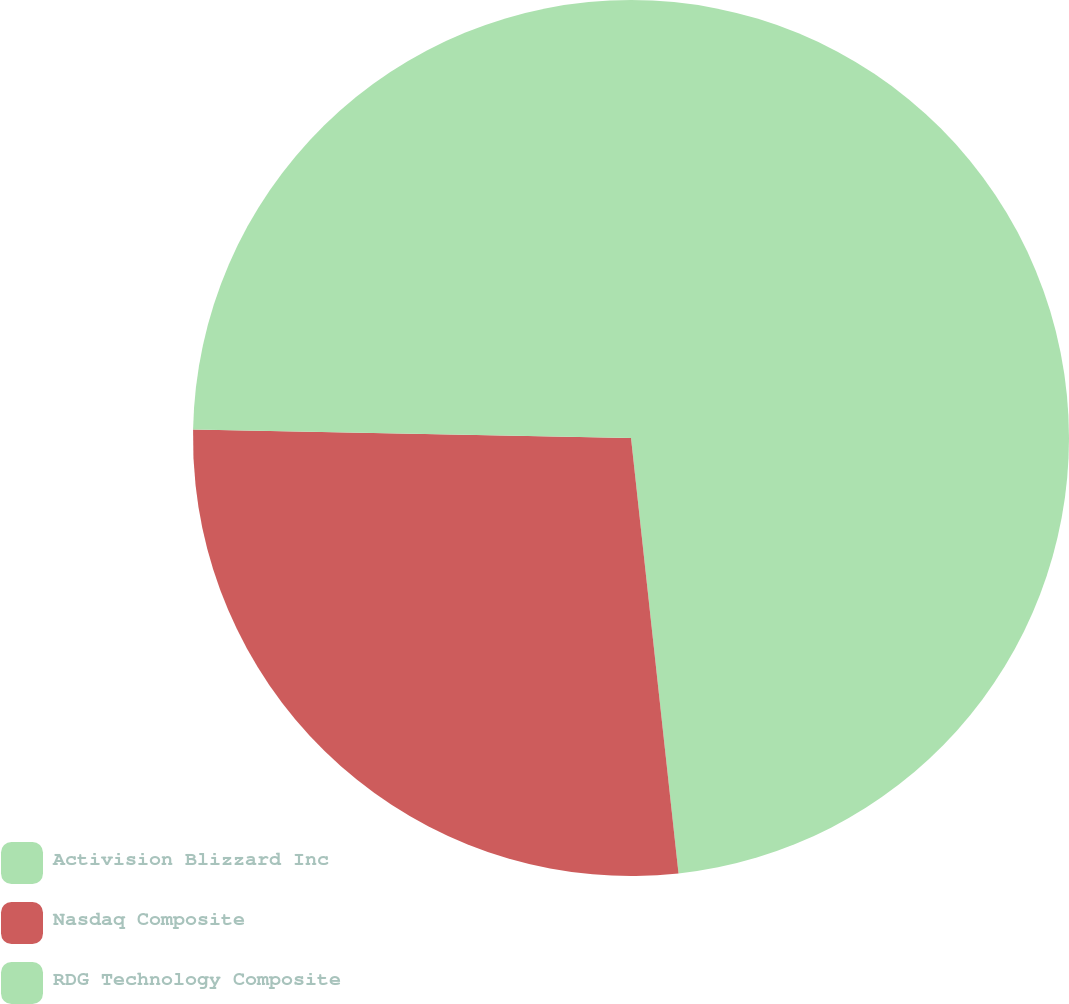Convert chart to OTSL. <chart><loc_0><loc_0><loc_500><loc_500><pie_chart><fcel>Activision Blizzard Inc<fcel>Nasdaq Composite<fcel>RDG Technology Composite<nl><fcel>48.27%<fcel>27.04%<fcel>24.69%<nl></chart> 